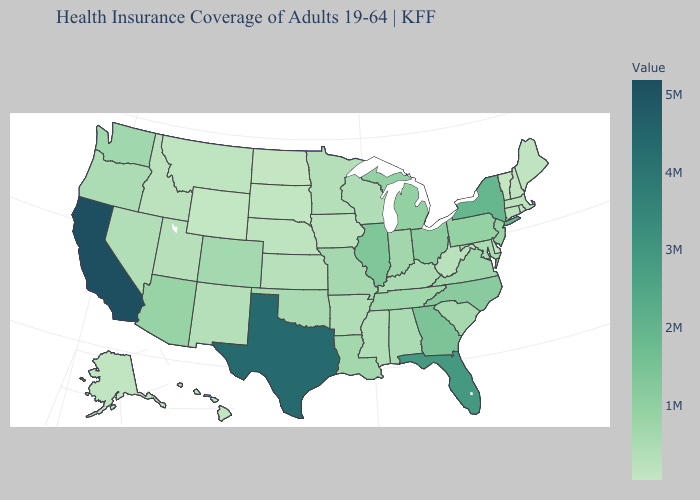Which states have the highest value in the USA?
Be succinct. California. Does the map have missing data?
Concise answer only. No. Among the states that border Kansas , which have the highest value?
Answer briefly. Colorado. Among the states that border Maryland , does Virginia have the highest value?
Concise answer only. No. Does West Virginia have a lower value than Ohio?
Quick response, please. Yes. Which states have the highest value in the USA?
Be succinct. California. 